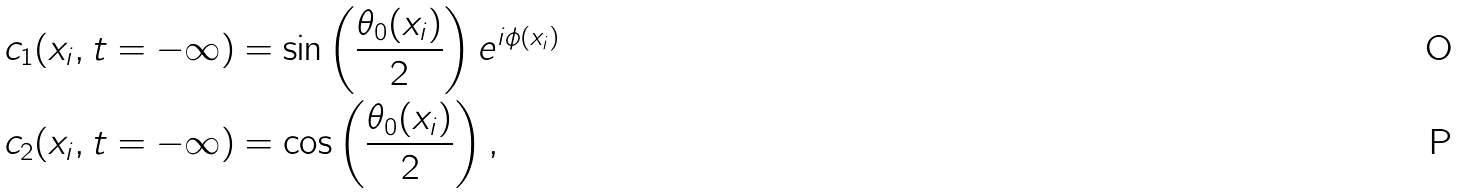Convert formula to latex. <formula><loc_0><loc_0><loc_500><loc_500>c _ { 1 } ( x _ { i } , t = - \infty ) & = \sin \left ( \frac { \theta _ { 0 } ( x _ { i } ) } { 2 } \right ) e ^ { i \phi ( x _ { i } ) } \\ c _ { 2 } ( x _ { i } , t = - \infty ) & = \cos \left ( \frac { \theta _ { 0 } ( x _ { i } ) } { 2 } \right ) ,</formula> 